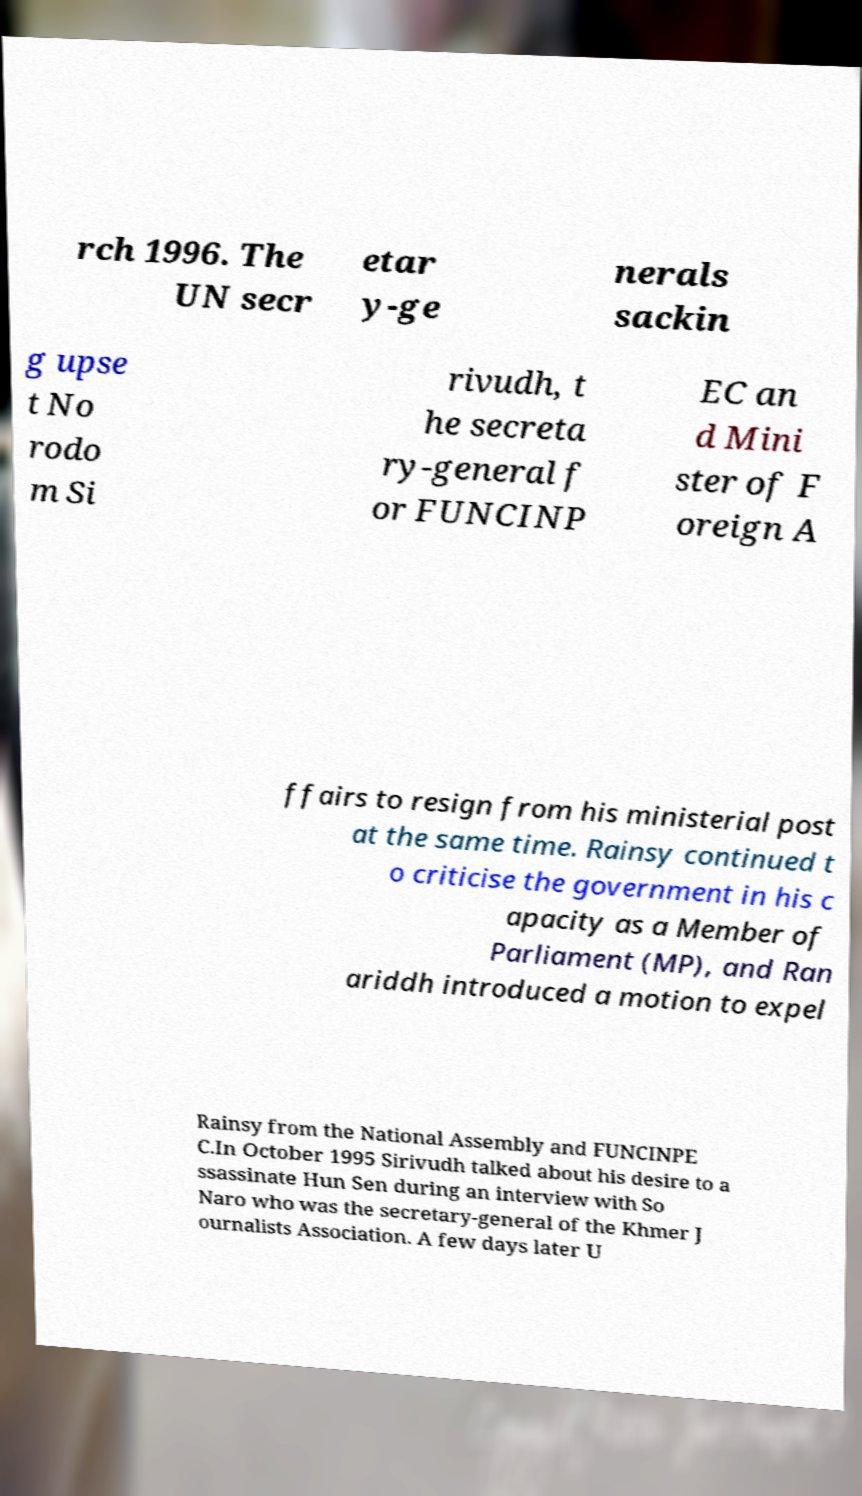Can you accurately transcribe the text from the provided image for me? rch 1996. The UN secr etar y-ge nerals sackin g upse t No rodo m Si rivudh, t he secreta ry-general f or FUNCINP EC an d Mini ster of F oreign A ffairs to resign from his ministerial post at the same time. Rainsy continued t o criticise the government in his c apacity as a Member of Parliament (MP), and Ran ariddh introduced a motion to expel Rainsy from the National Assembly and FUNCINPE C.In October 1995 Sirivudh talked about his desire to a ssassinate Hun Sen during an interview with So Naro who was the secretary-general of the Khmer J ournalists Association. A few days later U 